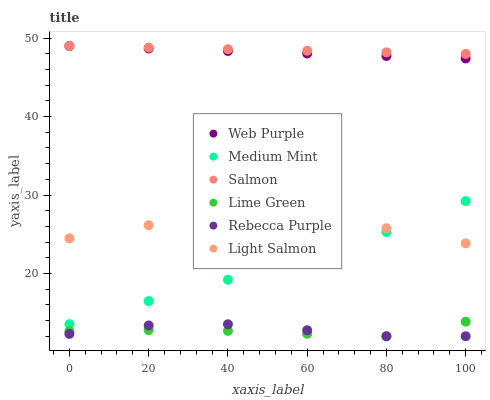Does Lime Green have the minimum area under the curve?
Answer yes or no. Yes. Does Salmon have the maximum area under the curve?
Answer yes or no. Yes. Does Light Salmon have the minimum area under the curve?
Answer yes or no. No. Does Light Salmon have the maximum area under the curve?
Answer yes or no. No. Is Salmon the smoothest?
Answer yes or no. Yes. Is Medium Mint the roughest?
Answer yes or no. Yes. Is Light Salmon the smoothest?
Answer yes or no. No. Is Light Salmon the roughest?
Answer yes or no. No. Does Rebecca Purple have the lowest value?
Answer yes or no. Yes. Does Light Salmon have the lowest value?
Answer yes or no. No. Does Web Purple have the highest value?
Answer yes or no. Yes. Does Light Salmon have the highest value?
Answer yes or no. No. Is Rebecca Purple less than Salmon?
Answer yes or no. Yes. Is Web Purple greater than Lime Green?
Answer yes or no. Yes. Does Rebecca Purple intersect Lime Green?
Answer yes or no. Yes. Is Rebecca Purple less than Lime Green?
Answer yes or no. No. Is Rebecca Purple greater than Lime Green?
Answer yes or no. No. Does Rebecca Purple intersect Salmon?
Answer yes or no. No. 